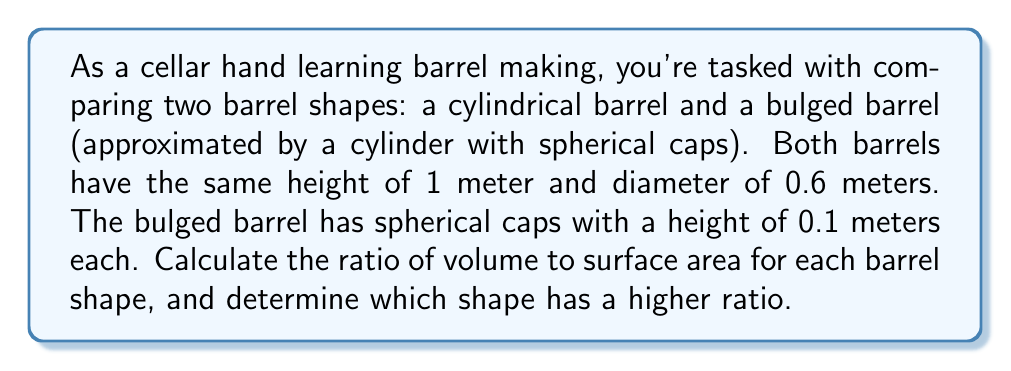Help me with this question. Let's approach this step-by-step:

1. Cylindrical Barrel:
   Volume: $V_c = \pi r^2 h$
   Surface Area: $SA_c = 2\pi r^2 + 2\pi rh$
   
   Where $r = 0.3$ m and $h = 1$ m
   
   $V_c = \pi (0.3)^2 (1) = 0.2827$ m³
   $SA_c = 2\pi (0.3)^2 + 2\pi (0.3)(1) = 1.1310$ m²
   
   Ratio: $\frac{V_c}{SA_c} = \frac{0.2827}{1.1310} = 0.2499$ m

2. Bulged Barrel:
   Volume: $V_b = V_{cylinder} + 2V_{spherical cap}$
   Surface Area: $SA_b = SA_{cylinder body} + 2SA_{spherical cap}$
   
   Cylinder part: $h_{cyl} = 1 - 2(0.1) = 0.8$ m
   $V_{cylinder} = \pi r^2 h_{cyl} = \pi (0.3)^2 (0.8) = 0.2262$ m³
   $SA_{cylinder body} = 2\pi rh_{cyl} = 2\pi (0.3)(0.8) = 1.5080$ m²
   
   Spherical cap: $r_{cap} = \frac{r^2 + h_{cap}^2}{2h_{cap}} = \frac{0.3^2 + 0.1^2}{2(0.1)} = 0.4525$ m
   $V_{spherical cap} = \frac{1}{3}\pi h_{cap}^2 (3r_{cap} - h_{cap}) = 0.0141$ m³
   $SA_{spherical cap} = 2\pi r_{cap}h_{cap} = 0.2844$ m²
   
   $V_b = 0.2262 + 2(0.0141) = 0.2544$ m³
   $SA_b = 1.5080 + 2(0.2844) = 2.0768$ m²
   
   Ratio: $\frac{V_b}{SA_b} = \frac{0.2544}{2.0768} = 0.1225$ m

3. Comparison:
   Cylindrical Barrel Ratio: 0.2499 m
   Bulged Barrel Ratio: 0.1225 m
Answer: Cylindrical barrel: 0.2499 m; Bulged barrel: 0.1225 m; Cylindrical has higher ratio. 